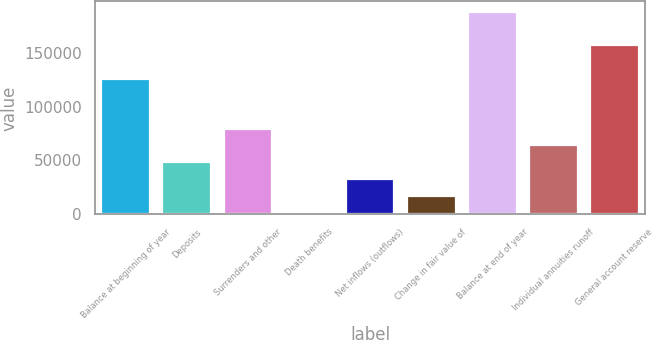<chart> <loc_0><loc_0><loc_500><loc_500><bar_chart><fcel>Balance at beginning of year<fcel>Deposits<fcel>Surrenders and other<fcel>Death benefits<fcel>Net inflows (outflows)<fcel>Change in fair value of<fcel>Balance at end of year<fcel>Individual annuities runoff<fcel>General account reserve<nl><fcel>126265<fcel>48391.4<fcel>79541<fcel>1667<fcel>32816.6<fcel>17241.8<fcel>188565<fcel>63966.2<fcel>157415<nl></chart> 